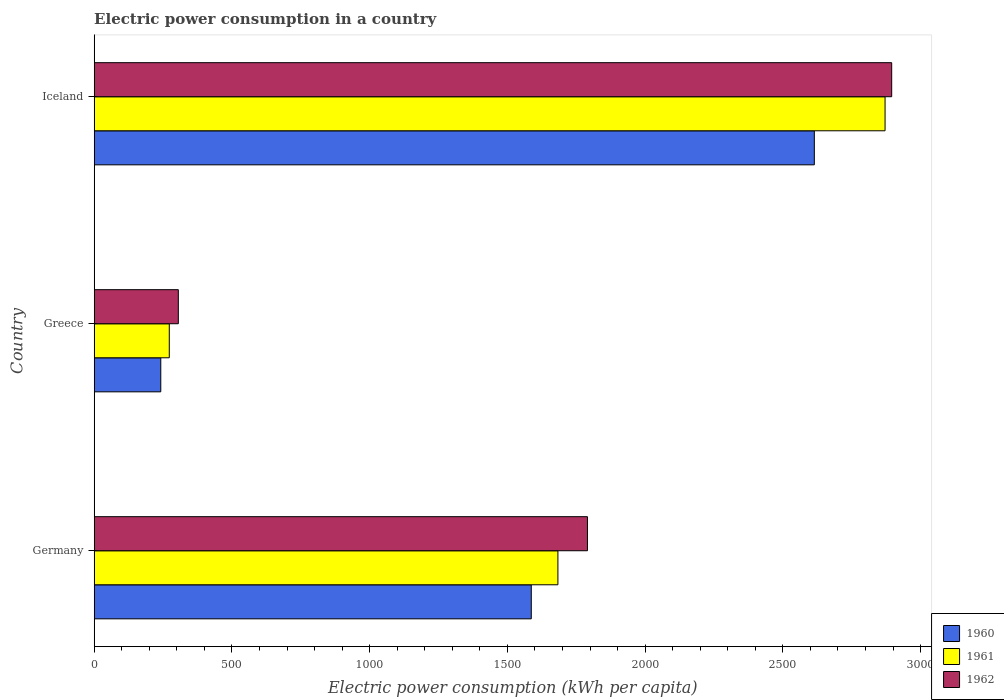How many different coloured bars are there?
Your answer should be very brief. 3. How many bars are there on the 1st tick from the top?
Ensure brevity in your answer.  3. How many bars are there on the 2nd tick from the bottom?
Keep it short and to the point. 3. What is the electric power consumption in in 1962 in Germany?
Provide a short and direct response. 1790.69. Across all countries, what is the maximum electric power consumption in in 1960?
Keep it short and to the point. 2614.28. Across all countries, what is the minimum electric power consumption in in 1962?
Keep it short and to the point. 305.39. In which country was the electric power consumption in in 1960 minimum?
Offer a very short reply. Greece. What is the total electric power consumption in in 1961 in the graph?
Your answer should be very brief. 4827.02. What is the difference between the electric power consumption in in 1961 in Germany and that in Iceland?
Ensure brevity in your answer.  -1187.63. What is the difference between the electric power consumption in in 1961 in Greece and the electric power consumption in in 1962 in Iceland?
Provide a succinct answer. -2622.52. What is the average electric power consumption in in 1961 per country?
Ensure brevity in your answer.  1609.01. What is the difference between the electric power consumption in in 1961 and electric power consumption in in 1960 in Greece?
Offer a terse response. 30.84. In how many countries, is the electric power consumption in in 1960 greater than 300 kWh per capita?
Provide a succinct answer. 2. What is the ratio of the electric power consumption in in 1960 in Germany to that in Iceland?
Offer a terse response. 0.61. What is the difference between the highest and the second highest electric power consumption in in 1961?
Give a very brief answer. 1187.63. What is the difference between the highest and the lowest electric power consumption in in 1960?
Your answer should be compact. 2372.56. What does the 1st bar from the bottom in Greece represents?
Your answer should be compact. 1960. Is it the case that in every country, the sum of the electric power consumption in in 1961 and electric power consumption in in 1962 is greater than the electric power consumption in in 1960?
Ensure brevity in your answer.  Yes. Are the values on the major ticks of X-axis written in scientific E-notation?
Provide a succinct answer. No. Does the graph contain any zero values?
Make the answer very short. No. Does the graph contain grids?
Offer a terse response. No. How many legend labels are there?
Your answer should be compact. 3. What is the title of the graph?
Your response must be concise. Electric power consumption in a country. What is the label or title of the X-axis?
Your response must be concise. Electric power consumption (kWh per capita). What is the label or title of the Y-axis?
Provide a succinct answer. Country. What is the Electric power consumption (kWh per capita) of 1960 in Germany?
Offer a terse response. 1586.75. What is the Electric power consumption (kWh per capita) of 1961 in Germany?
Keep it short and to the point. 1683.41. What is the Electric power consumption (kWh per capita) of 1962 in Germany?
Ensure brevity in your answer.  1790.69. What is the Electric power consumption (kWh per capita) of 1960 in Greece?
Keep it short and to the point. 241.73. What is the Electric power consumption (kWh per capita) in 1961 in Greece?
Your answer should be compact. 272.56. What is the Electric power consumption (kWh per capita) in 1962 in Greece?
Your response must be concise. 305.39. What is the Electric power consumption (kWh per capita) in 1960 in Iceland?
Offer a very short reply. 2614.28. What is the Electric power consumption (kWh per capita) of 1961 in Iceland?
Offer a very short reply. 2871.04. What is the Electric power consumption (kWh per capita) in 1962 in Iceland?
Offer a very short reply. 2895.09. Across all countries, what is the maximum Electric power consumption (kWh per capita) of 1960?
Your answer should be compact. 2614.28. Across all countries, what is the maximum Electric power consumption (kWh per capita) of 1961?
Offer a terse response. 2871.04. Across all countries, what is the maximum Electric power consumption (kWh per capita) in 1962?
Offer a terse response. 2895.09. Across all countries, what is the minimum Electric power consumption (kWh per capita) in 1960?
Keep it short and to the point. 241.73. Across all countries, what is the minimum Electric power consumption (kWh per capita) in 1961?
Keep it short and to the point. 272.56. Across all countries, what is the minimum Electric power consumption (kWh per capita) in 1962?
Keep it short and to the point. 305.39. What is the total Electric power consumption (kWh per capita) of 1960 in the graph?
Your answer should be compact. 4442.76. What is the total Electric power consumption (kWh per capita) in 1961 in the graph?
Your response must be concise. 4827.02. What is the total Electric power consumption (kWh per capita) of 1962 in the graph?
Your answer should be very brief. 4991.16. What is the difference between the Electric power consumption (kWh per capita) of 1960 in Germany and that in Greece?
Ensure brevity in your answer.  1345.02. What is the difference between the Electric power consumption (kWh per capita) in 1961 in Germany and that in Greece?
Ensure brevity in your answer.  1410.85. What is the difference between the Electric power consumption (kWh per capita) in 1962 in Germany and that in Greece?
Provide a short and direct response. 1485.3. What is the difference between the Electric power consumption (kWh per capita) in 1960 in Germany and that in Iceland?
Provide a succinct answer. -1027.53. What is the difference between the Electric power consumption (kWh per capita) of 1961 in Germany and that in Iceland?
Provide a short and direct response. -1187.63. What is the difference between the Electric power consumption (kWh per capita) of 1962 in Germany and that in Iceland?
Provide a succinct answer. -1104.4. What is the difference between the Electric power consumption (kWh per capita) of 1960 in Greece and that in Iceland?
Provide a short and direct response. -2372.56. What is the difference between the Electric power consumption (kWh per capita) of 1961 in Greece and that in Iceland?
Offer a very short reply. -2598.48. What is the difference between the Electric power consumption (kWh per capita) in 1962 in Greece and that in Iceland?
Your response must be concise. -2589.7. What is the difference between the Electric power consumption (kWh per capita) in 1960 in Germany and the Electric power consumption (kWh per capita) in 1961 in Greece?
Offer a terse response. 1314.19. What is the difference between the Electric power consumption (kWh per capita) in 1960 in Germany and the Electric power consumption (kWh per capita) in 1962 in Greece?
Your answer should be compact. 1281.36. What is the difference between the Electric power consumption (kWh per capita) in 1961 in Germany and the Electric power consumption (kWh per capita) in 1962 in Greece?
Offer a terse response. 1378.03. What is the difference between the Electric power consumption (kWh per capita) of 1960 in Germany and the Electric power consumption (kWh per capita) of 1961 in Iceland?
Give a very brief answer. -1284.29. What is the difference between the Electric power consumption (kWh per capita) of 1960 in Germany and the Electric power consumption (kWh per capita) of 1962 in Iceland?
Keep it short and to the point. -1308.34. What is the difference between the Electric power consumption (kWh per capita) of 1961 in Germany and the Electric power consumption (kWh per capita) of 1962 in Iceland?
Provide a succinct answer. -1211.67. What is the difference between the Electric power consumption (kWh per capita) in 1960 in Greece and the Electric power consumption (kWh per capita) in 1961 in Iceland?
Provide a short and direct response. -2629.32. What is the difference between the Electric power consumption (kWh per capita) of 1960 in Greece and the Electric power consumption (kWh per capita) of 1962 in Iceland?
Give a very brief answer. -2653.36. What is the difference between the Electric power consumption (kWh per capita) of 1961 in Greece and the Electric power consumption (kWh per capita) of 1962 in Iceland?
Provide a short and direct response. -2622.52. What is the average Electric power consumption (kWh per capita) of 1960 per country?
Offer a very short reply. 1480.92. What is the average Electric power consumption (kWh per capita) of 1961 per country?
Offer a very short reply. 1609.01. What is the average Electric power consumption (kWh per capita) of 1962 per country?
Your answer should be compact. 1663.72. What is the difference between the Electric power consumption (kWh per capita) in 1960 and Electric power consumption (kWh per capita) in 1961 in Germany?
Provide a succinct answer. -96.67. What is the difference between the Electric power consumption (kWh per capita) of 1960 and Electric power consumption (kWh per capita) of 1962 in Germany?
Provide a succinct answer. -203.94. What is the difference between the Electric power consumption (kWh per capita) in 1961 and Electric power consumption (kWh per capita) in 1962 in Germany?
Offer a terse response. -107.27. What is the difference between the Electric power consumption (kWh per capita) of 1960 and Electric power consumption (kWh per capita) of 1961 in Greece?
Provide a short and direct response. -30.84. What is the difference between the Electric power consumption (kWh per capita) of 1960 and Electric power consumption (kWh per capita) of 1962 in Greece?
Your answer should be very brief. -63.66. What is the difference between the Electric power consumption (kWh per capita) of 1961 and Electric power consumption (kWh per capita) of 1962 in Greece?
Provide a short and direct response. -32.83. What is the difference between the Electric power consumption (kWh per capita) of 1960 and Electric power consumption (kWh per capita) of 1961 in Iceland?
Your response must be concise. -256.76. What is the difference between the Electric power consumption (kWh per capita) of 1960 and Electric power consumption (kWh per capita) of 1962 in Iceland?
Your answer should be very brief. -280.8. What is the difference between the Electric power consumption (kWh per capita) of 1961 and Electric power consumption (kWh per capita) of 1962 in Iceland?
Keep it short and to the point. -24.04. What is the ratio of the Electric power consumption (kWh per capita) in 1960 in Germany to that in Greece?
Your response must be concise. 6.56. What is the ratio of the Electric power consumption (kWh per capita) of 1961 in Germany to that in Greece?
Provide a short and direct response. 6.18. What is the ratio of the Electric power consumption (kWh per capita) of 1962 in Germany to that in Greece?
Your answer should be compact. 5.86. What is the ratio of the Electric power consumption (kWh per capita) of 1960 in Germany to that in Iceland?
Your answer should be very brief. 0.61. What is the ratio of the Electric power consumption (kWh per capita) in 1961 in Germany to that in Iceland?
Your answer should be compact. 0.59. What is the ratio of the Electric power consumption (kWh per capita) of 1962 in Germany to that in Iceland?
Your response must be concise. 0.62. What is the ratio of the Electric power consumption (kWh per capita) of 1960 in Greece to that in Iceland?
Provide a succinct answer. 0.09. What is the ratio of the Electric power consumption (kWh per capita) of 1961 in Greece to that in Iceland?
Keep it short and to the point. 0.09. What is the ratio of the Electric power consumption (kWh per capita) in 1962 in Greece to that in Iceland?
Provide a short and direct response. 0.11. What is the difference between the highest and the second highest Electric power consumption (kWh per capita) in 1960?
Keep it short and to the point. 1027.53. What is the difference between the highest and the second highest Electric power consumption (kWh per capita) in 1961?
Make the answer very short. 1187.63. What is the difference between the highest and the second highest Electric power consumption (kWh per capita) in 1962?
Provide a short and direct response. 1104.4. What is the difference between the highest and the lowest Electric power consumption (kWh per capita) of 1960?
Ensure brevity in your answer.  2372.56. What is the difference between the highest and the lowest Electric power consumption (kWh per capita) in 1961?
Ensure brevity in your answer.  2598.48. What is the difference between the highest and the lowest Electric power consumption (kWh per capita) of 1962?
Keep it short and to the point. 2589.7. 